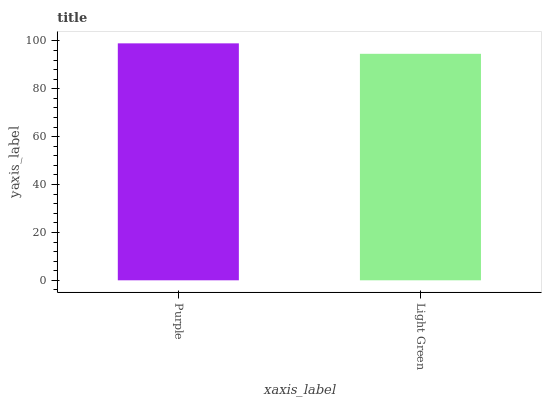Is Light Green the minimum?
Answer yes or no. Yes. Is Purple the maximum?
Answer yes or no. Yes. Is Light Green the maximum?
Answer yes or no. No. Is Purple greater than Light Green?
Answer yes or no. Yes. Is Light Green less than Purple?
Answer yes or no. Yes. Is Light Green greater than Purple?
Answer yes or no. No. Is Purple less than Light Green?
Answer yes or no. No. Is Purple the high median?
Answer yes or no. Yes. Is Light Green the low median?
Answer yes or no. Yes. Is Light Green the high median?
Answer yes or no. No. Is Purple the low median?
Answer yes or no. No. 